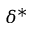Convert formula to latex. <formula><loc_0><loc_0><loc_500><loc_500>\delta ^ { * }</formula> 